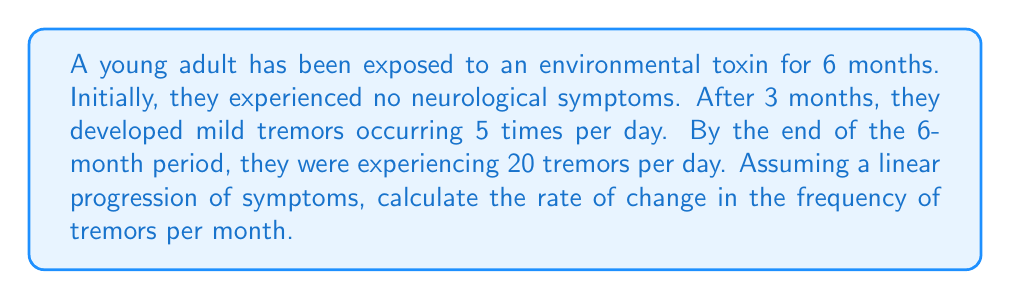Provide a solution to this math problem. To solve this problem, we need to use the rate of change formula:

$$ \text{Rate of Change} = \frac{\text{Change in y}}{\text{Change in x}} $$

Let's identify our variables:
- x = time in months
- y = number of tremors per day

We have two data points:
1. At 3 months: 5 tremors per day
2. At 6 months: 20 tremors per day

Now, let's plug these into our formula:

$$ \text{Rate of Change} = \frac{y_2 - y_1}{x_2 - x_1} = \frac{20 - 5}{6 - 3} = \frac{15}{3} = 5 $$

This means the frequency of tremors is increasing by 5 per day each month.

To verify, we can check:
- At 3 months: 5 tremors
- At 4 months: 5 + 5 = 10 tremors
- At 5 months: 10 + 5 = 15 tremors
- At 6 months: 15 + 5 = 20 tremors

This confirms our calculation is correct.
Answer: The rate of change in the frequency of tremors is 5 tremors per day per month. 